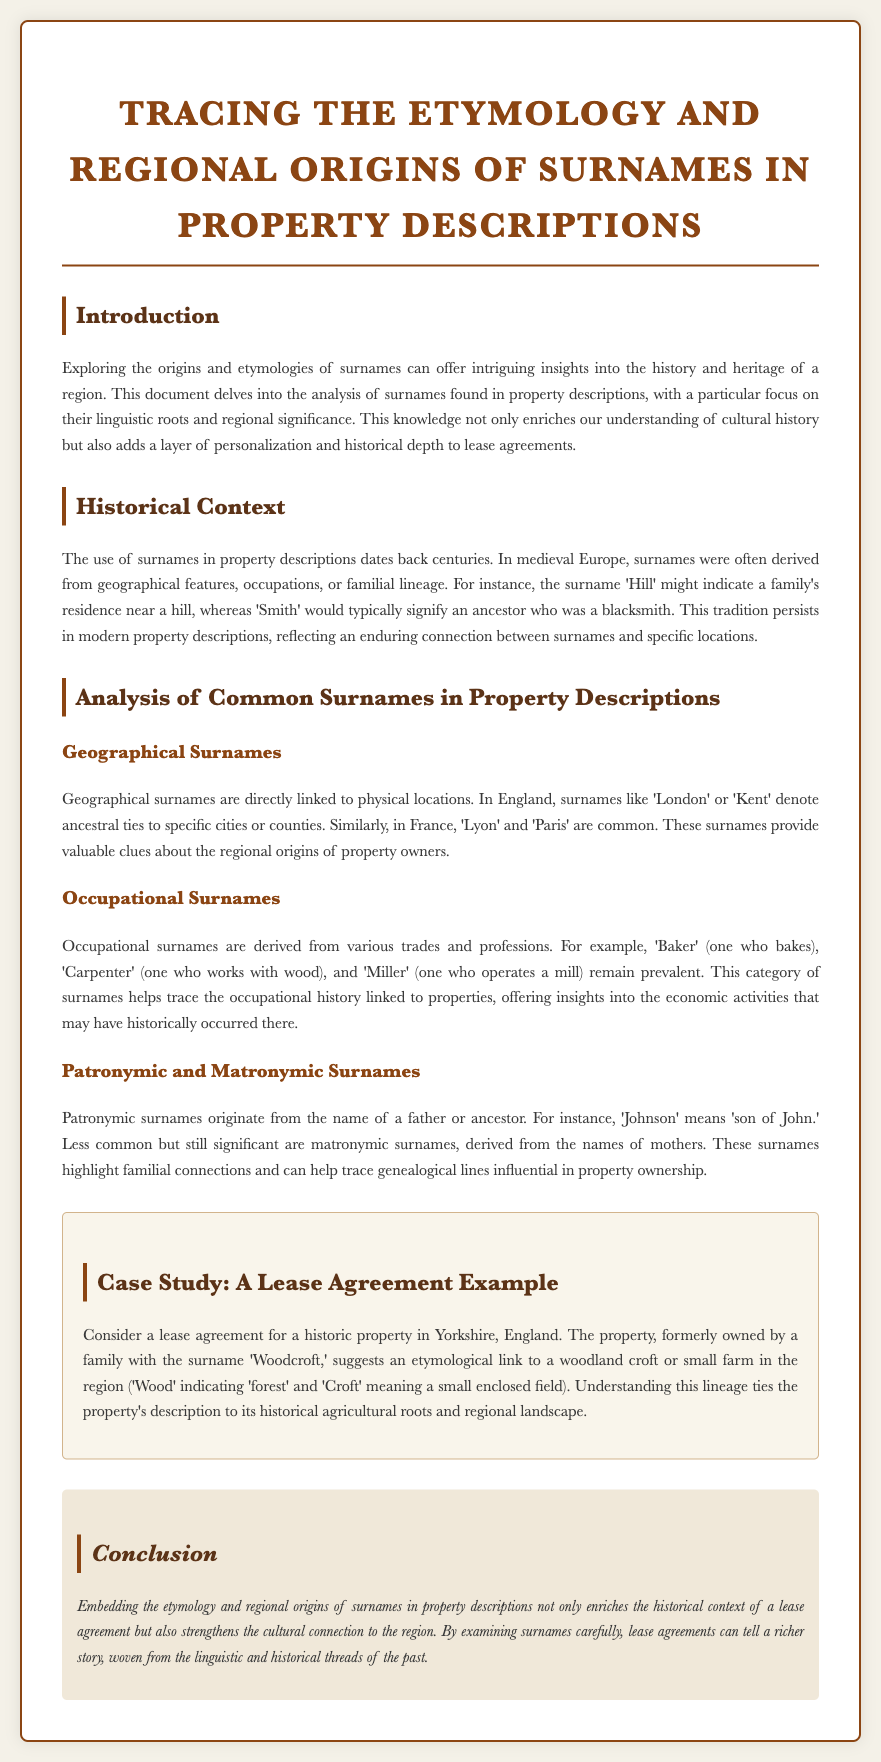What is the title of the document? The title is prominently displayed at the top of the document.
Answer: Tracing the Etymology and Regional Origins of Surnames in Property Descriptions What is a geographical surname example mentioned? The document provides specific examples of geographical surnames within the context of property descriptions.
Answer: London What does the term 'crofts' indicate in the case study? The document explains the meaning of 'croft' in the context of property descriptions and etymology.
Answer: small enclosed field What are occupational surnames derived from? The document provides information about the origin of these types of surnames.
Answer: trades and professions In which historical region does the case study take place? The location of the historic property is stated within the case study section.
Answer: Yorkshire What are patronymic surnames based on? The explanation of patronymic surnames is provided in the document.
Answer: names of fathers What do surnames like 'Smith' signify? The document categorizes certain surnames according to their origins and meanings.
Answer: blacksmith What is the primary focus of this document? The document specifies its main theme at the beginning.
Answer: surname origins What year is indicated for the document knowledge? The context of the data mentioned at the beginning of the prompt provides a time frame.
Answer: 2023 